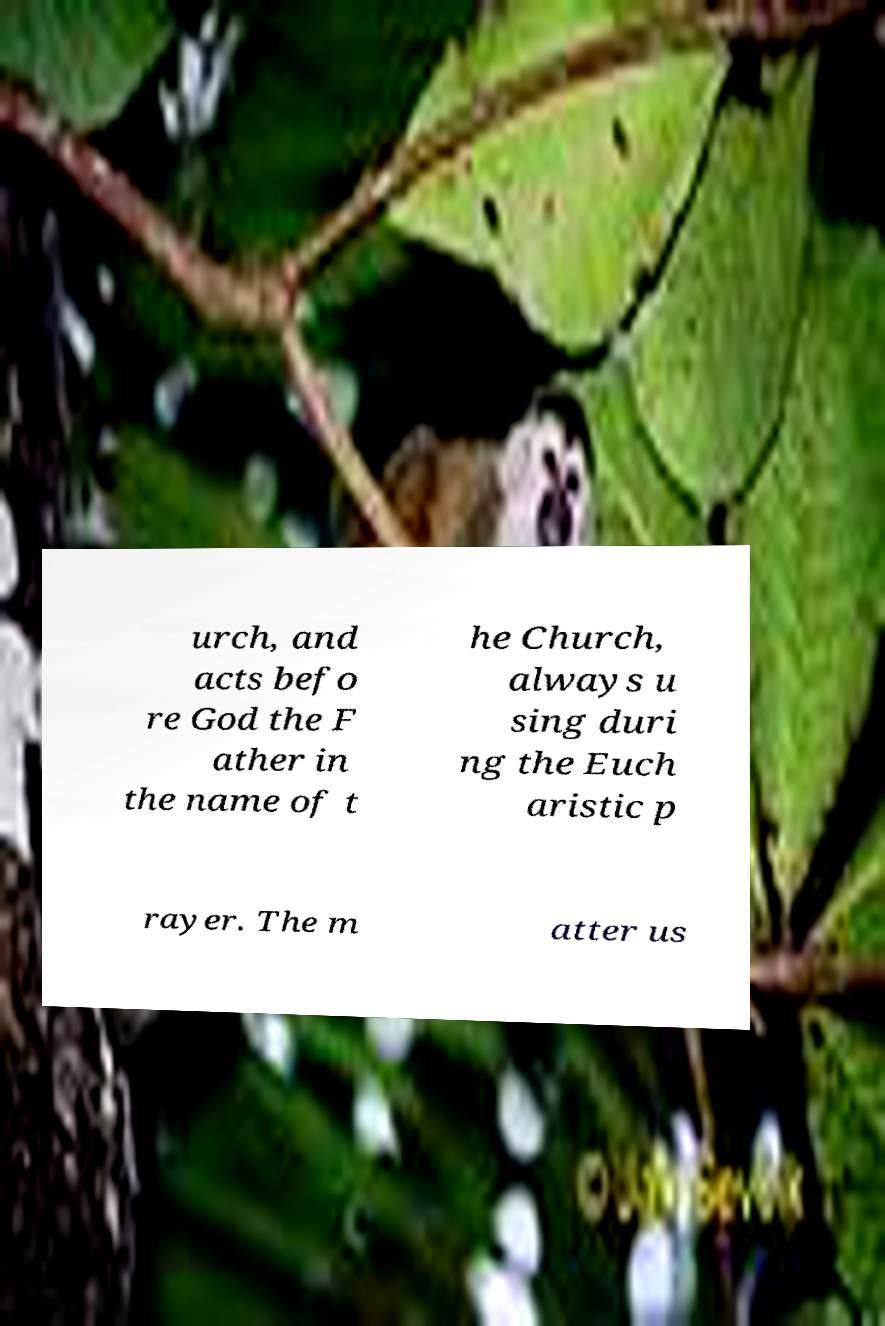For documentation purposes, I need the text within this image transcribed. Could you provide that? urch, and acts befo re God the F ather in the name of t he Church, always u sing duri ng the Euch aristic p rayer. The m atter us 